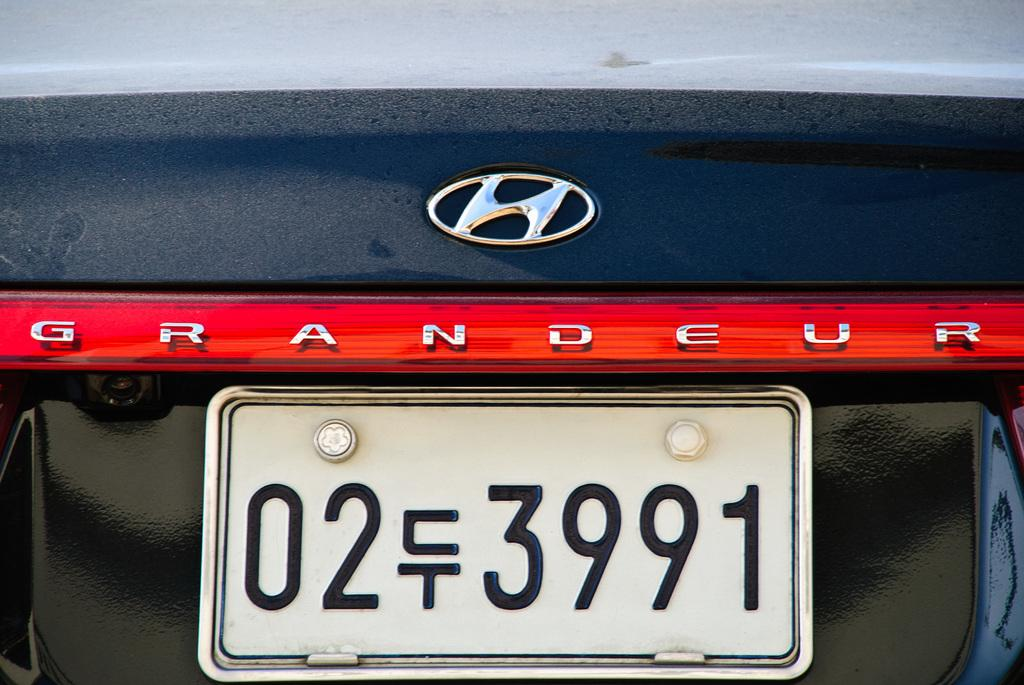<image>
Offer a succinct explanation of the picture presented. A navy blue Hyundai Grandeur has a black and white license plate. 